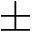<formula> <loc_0><loc_0><loc_500><loc_500>\pm</formula> 